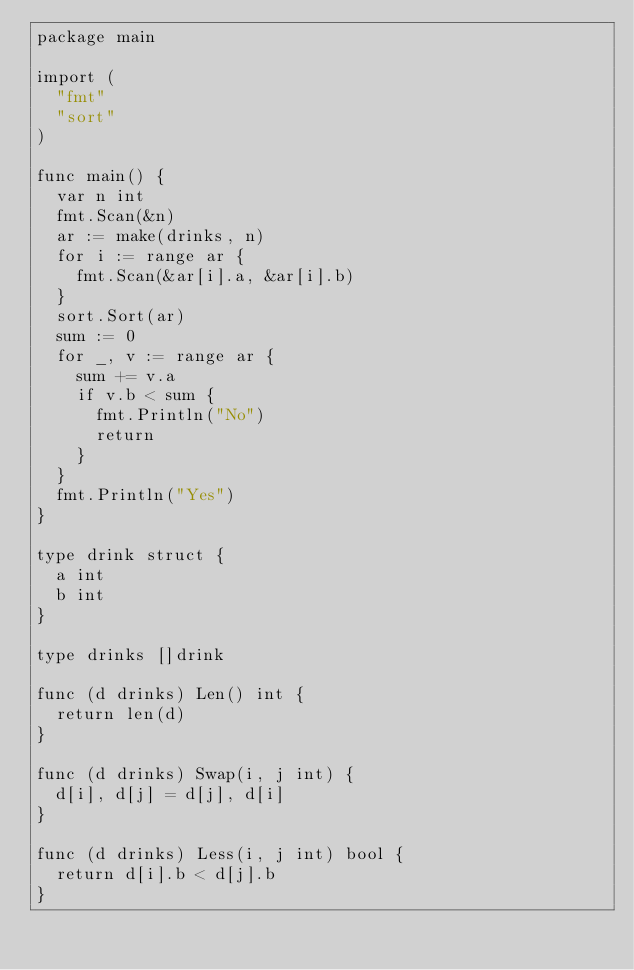<code> <loc_0><loc_0><loc_500><loc_500><_Go_>package main

import (
	"fmt"
	"sort"
)

func main() {
	var n int
	fmt.Scan(&n)
	ar := make(drinks, n)
	for i := range ar {
		fmt.Scan(&ar[i].a, &ar[i].b)
	}
	sort.Sort(ar)
	sum := 0
	for _, v := range ar {
		sum += v.a
		if v.b < sum {
			fmt.Println("No")
			return
		}
	}
	fmt.Println("Yes")
}

type drink struct {
	a int
	b int
}

type drinks []drink

func (d drinks) Len() int {
	return len(d)
}

func (d drinks) Swap(i, j int) {
	d[i], d[j] = d[j], d[i]
}

func (d drinks) Less(i, j int) bool {
	return d[i].b < d[j].b
}
</code> 